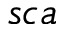Convert formula to latex. <formula><loc_0><loc_0><loc_500><loc_500>s c a</formula> 